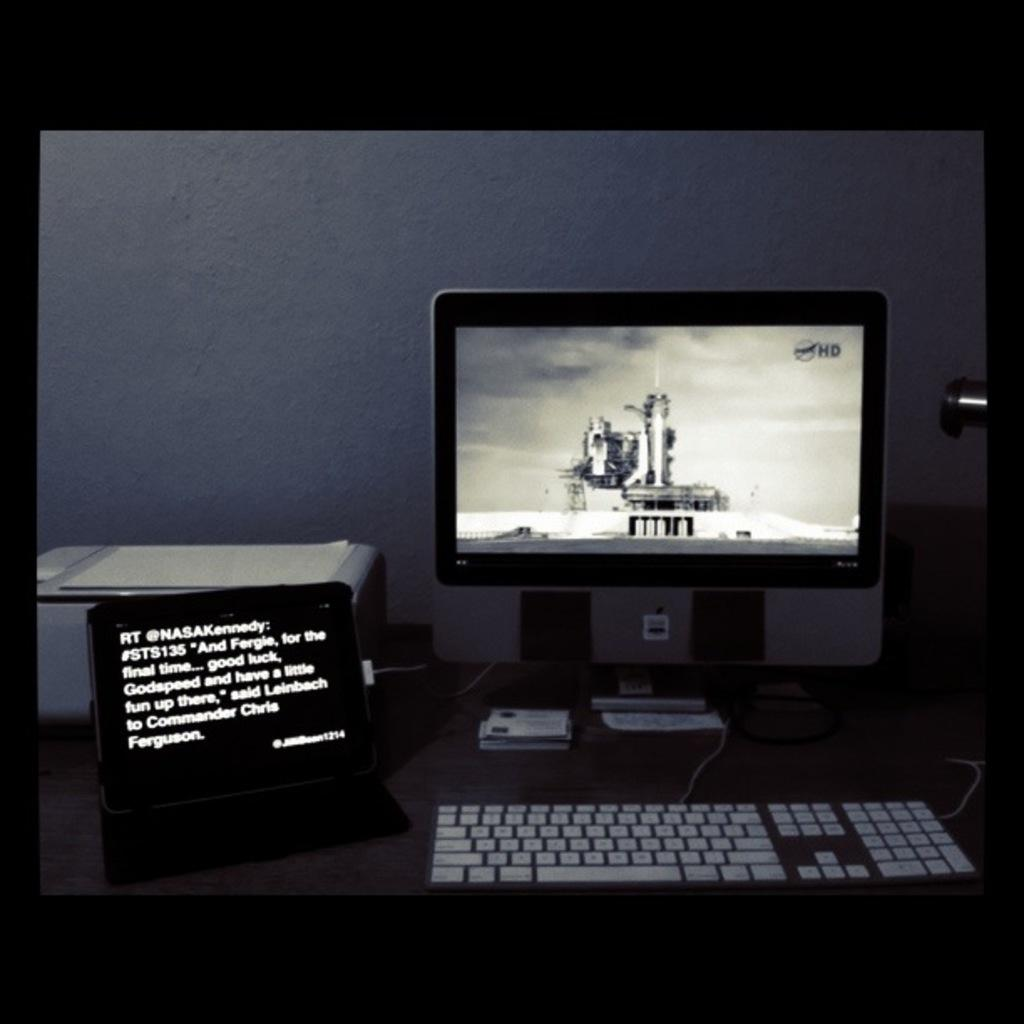<image>
Write a terse but informative summary of the picture. a computer showing a space shuttle launch and sign reading And Fergie Good Luck 